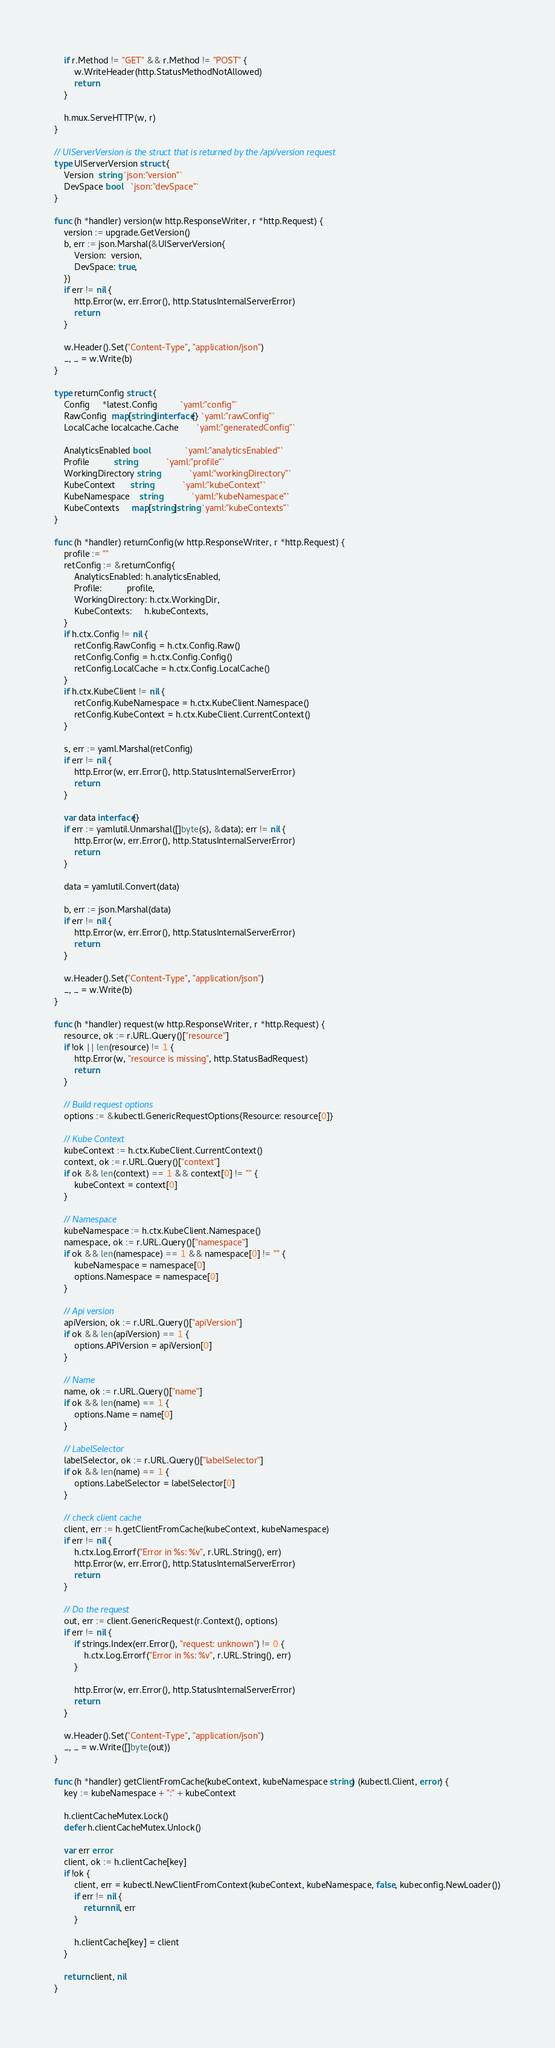Convert code to text. <code><loc_0><loc_0><loc_500><loc_500><_Go_>	if r.Method != "GET" && r.Method != "POST" {
		w.WriteHeader(http.StatusMethodNotAllowed)
		return
	}

	h.mux.ServeHTTP(w, r)
}

// UIServerVersion is the struct that is returned by the /api/version request
type UIServerVersion struct {
	Version  string `json:"version"`
	DevSpace bool   `json:"devSpace"`
}

func (h *handler) version(w http.ResponseWriter, r *http.Request) {
	version := upgrade.GetVersion()
	b, err := json.Marshal(&UIServerVersion{
		Version:  version,
		DevSpace: true,
	})
	if err != nil {
		http.Error(w, err.Error(), http.StatusInternalServerError)
		return
	}

	w.Header().Set("Content-Type", "application/json")
	_, _ = w.Write(b)
}

type returnConfig struct {
	Config     *latest.Config         `yaml:"config"`
	RawConfig  map[string]interface{} `yaml:"rawConfig"`
	LocalCache localcache.Cache       `yaml:"generatedConfig"`

	AnalyticsEnabled bool              `yaml:"analyticsEnabled"`
	Profile          string            `yaml:"profile"`
	WorkingDirectory string            `yaml:"workingDirectory"`
	KubeContext      string            `yaml:"kubeContext"`
	KubeNamespace    string            `yaml:"kubeNamespace"`
	KubeContexts     map[string]string `yaml:"kubeContexts"`
}

func (h *handler) returnConfig(w http.ResponseWriter, r *http.Request) {
	profile := ""
	retConfig := &returnConfig{
		AnalyticsEnabled: h.analyticsEnabled,
		Profile:          profile,
		WorkingDirectory: h.ctx.WorkingDir,
		KubeContexts:     h.kubeContexts,
	}
	if h.ctx.Config != nil {
		retConfig.RawConfig = h.ctx.Config.Raw()
		retConfig.Config = h.ctx.Config.Config()
		retConfig.LocalCache = h.ctx.Config.LocalCache()
	}
	if h.ctx.KubeClient != nil {
		retConfig.KubeNamespace = h.ctx.KubeClient.Namespace()
		retConfig.KubeContext = h.ctx.KubeClient.CurrentContext()
	}

	s, err := yaml.Marshal(retConfig)
	if err != nil {
		http.Error(w, err.Error(), http.StatusInternalServerError)
		return
	}

	var data interface{}
	if err := yamlutil.Unmarshal([]byte(s), &data); err != nil {
		http.Error(w, err.Error(), http.StatusInternalServerError)
		return
	}

	data = yamlutil.Convert(data)

	b, err := json.Marshal(data)
	if err != nil {
		http.Error(w, err.Error(), http.StatusInternalServerError)
		return
	}

	w.Header().Set("Content-Type", "application/json")
	_, _ = w.Write(b)
}

func (h *handler) request(w http.ResponseWriter, r *http.Request) {
	resource, ok := r.URL.Query()["resource"]
	if !ok || len(resource) != 1 {
		http.Error(w, "resource is missing", http.StatusBadRequest)
		return
	}

	// Build request options
	options := &kubectl.GenericRequestOptions{Resource: resource[0]}

	// Kube Context
	kubeContext := h.ctx.KubeClient.CurrentContext()
	context, ok := r.URL.Query()["context"]
	if ok && len(context) == 1 && context[0] != "" {
		kubeContext = context[0]
	}

	// Namespace
	kubeNamespace := h.ctx.KubeClient.Namespace()
	namespace, ok := r.URL.Query()["namespace"]
	if ok && len(namespace) == 1 && namespace[0] != "" {
		kubeNamespace = namespace[0]
		options.Namespace = namespace[0]
	}

	// Api version
	apiVersion, ok := r.URL.Query()["apiVersion"]
	if ok && len(apiVersion) == 1 {
		options.APIVersion = apiVersion[0]
	}

	// Name
	name, ok := r.URL.Query()["name"]
	if ok && len(name) == 1 {
		options.Name = name[0]
	}

	// LabelSelector
	labelSelector, ok := r.URL.Query()["labelSelector"]
	if ok && len(name) == 1 {
		options.LabelSelector = labelSelector[0]
	}

	// check client cache
	client, err := h.getClientFromCache(kubeContext, kubeNamespace)
	if err != nil {
		h.ctx.Log.Errorf("Error in %s: %v", r.URL.String(), err)
		http.Error(w, err.Error(), http.StatusInternalServerError)
		return
	}

	// Do the request
	out, err := client.GenericRequest(r.Context(), options)
	if err != nil {
		if strings.Index(err.Error(), "request: unknown") != 0 {
			h.ctx.Log.Errorf("Error in %s: %v", r.URL.String(), err)
		}

		http.Error(w, err.Error(), http.StatusInternalServerError)
		return
	}

	w.Header().Set("Content-Type", "application/json")
	_, _ = w.Write([]byte(out))
}

func (h *handler) getClientFromCache(kubeContext, kubeNamespace string) (kubectl.Client, error) {
	key := kubeNamespace + ":" + kubeContext

	h.clientCacheMutex.Lock()
	defer h.clientCacheMutex.Unlock()

	var err error
	client, ok := h.clientCache[key]
	if !ok {
		client, err = kubectl.NewClientFromContext(kubeContext, kubeNamespace, false, kubeconfig.NewLoader())
		if err != nil {
			return nil, err
		}

		h.clientCache[key] = client
	}

	return client, nil
}
</code> 